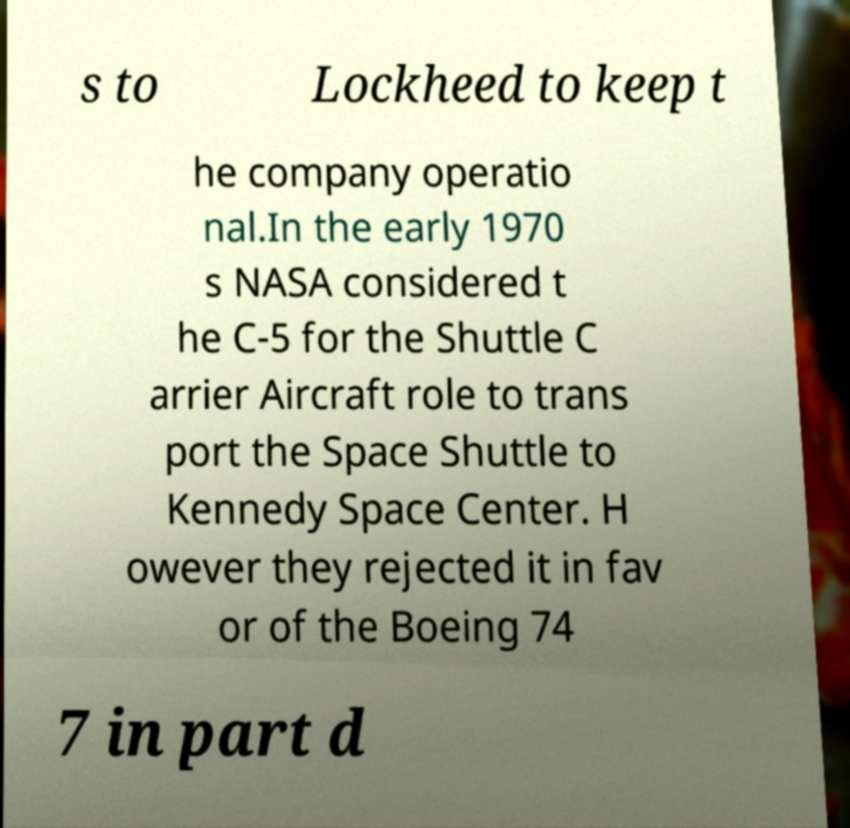What messages or text are displayed in this image? I need them in a readable, typed format. s to Lockheed to keep t he company operatio nal.In the early 1970 s NASA considered t he C-5 for the Shuttle C arrier Aircraft role to trans port the Space Shuttle to Kennedy Space Center. H owever they rejected it in fav or of the Boeing 74 7 in part d 